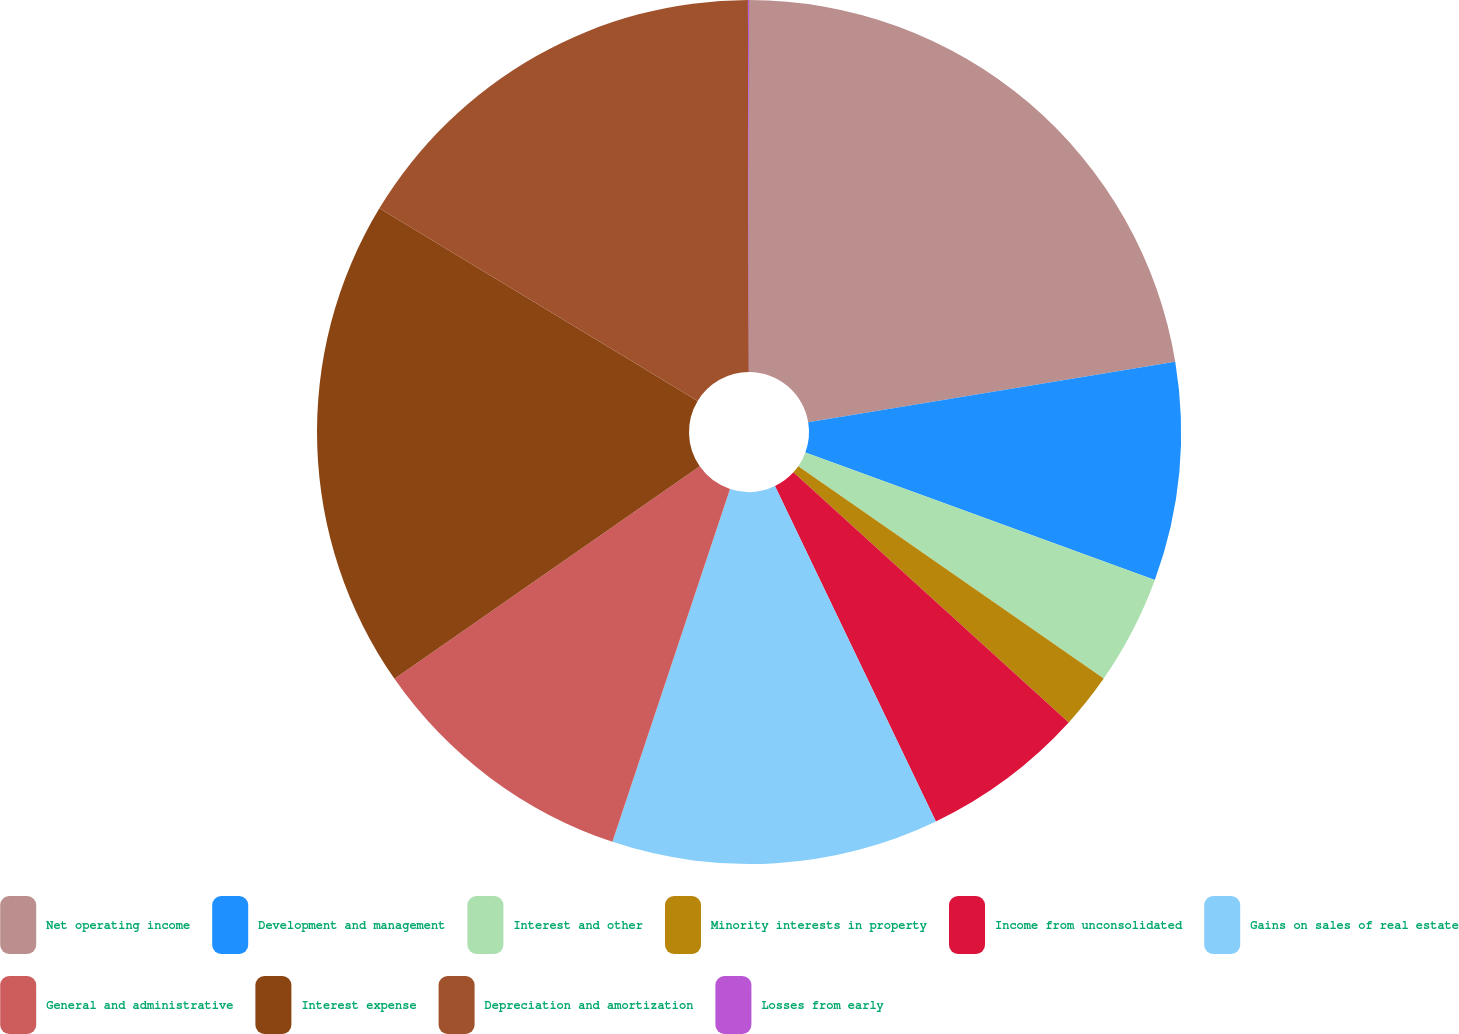Convert chart to OTSL. <chart><loc_0><loc_0><loc_500><loc_500><pie_chart><fcel>Net operating income<fcel>Development and management<fcel>Interest and other<fcel>Minority interests in property<fcel>Income from unconsolidated<fcel>Gains on sales of real estate<fcel>General and administrative<fcel>Interest expense<fcel>Depreciation and amortization<fcel>Losses from early<nl><fcel>22.4%<fcel>8.17%<fcel>4.1%<fcel>2.07%<fcel>6.14%<fcel>12.24%<fcel>10.2%<fcel>18.34%<fcel>16.3%<fcel>0.04%<nl></chart> 